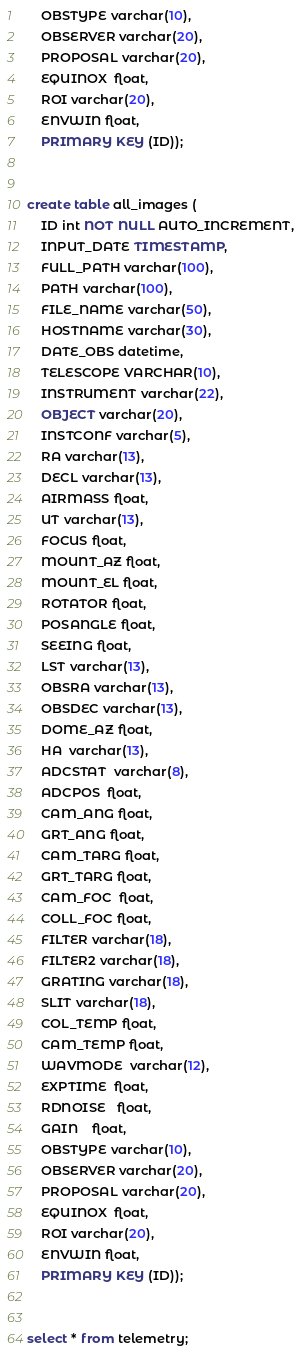<code> <loc_0><loc_0><loc_500><loc_500><_SQL_>    OBSTYPE varchar(10),
    OBSERVER varchar(20),
    PROPOSAL varchar(20),
    EQUINOX  float,
    ROI varchar(20),
    ENVWIN float,
    PRIMARY KEY (ID));


create table all_images (
    ID int NOT NULL AUTO_INCREMENT,
    INPUT_DATE TIMESTAMP,
    FULL_PATH varchar(100),
    PATH varchar(100),
    FILE_NAME varchar(50),
    HOSTNAME varchar(30),
    DATE_OBS datetime,
    TELESCOPE VARCHAR(10),
    INSTRUMENT varchar(22),
    OBJECT varchar(20),
    INSTCONF varchar(5),
    RA varchar(13),
    DECL varchar(13),
    AIRMASS float,
    UT varchar(13),
    FOCUS float,
    MOUNT_AZ float,
    MOUNT_EL float,
    ROTATOR float,
    POSANGLE float,
    SEEING float,
    LST varchar(13),
    OBSRA varchar(13),
    OBSDEC varchar(13),
    DOME_AZ float,
    HA  varchar(13),
    ADCSTAT  varchar(8),
    ADCPOS  float,
    CAM_ANG float,
    GRT_ANG float,
    CAM_TARG float,
    GRT_TARG float,
    CAM_FOC  float,
    COLL_FOC float,
    FILTER varchar(18),
    FILTER2 varchar(18),
    GRATING varchar(18),
    SLIT varchar(18),
    COL_TEMP float,
    CAM_TEMP float,
    WAVMODE  varchar(12),
    EXPTIME  float,
    RDNOISE   float,
    GAIN    float,
    OBSTYPE varchar(10),
    OBSERVER varchar(20),
    PROPOSAL varchar(20),
    EQUINOX  float,
    ROI varchar(20),
    ENVWIN float,
    PRIMARY KEY (ID));


select * from telemetry;

</code> 